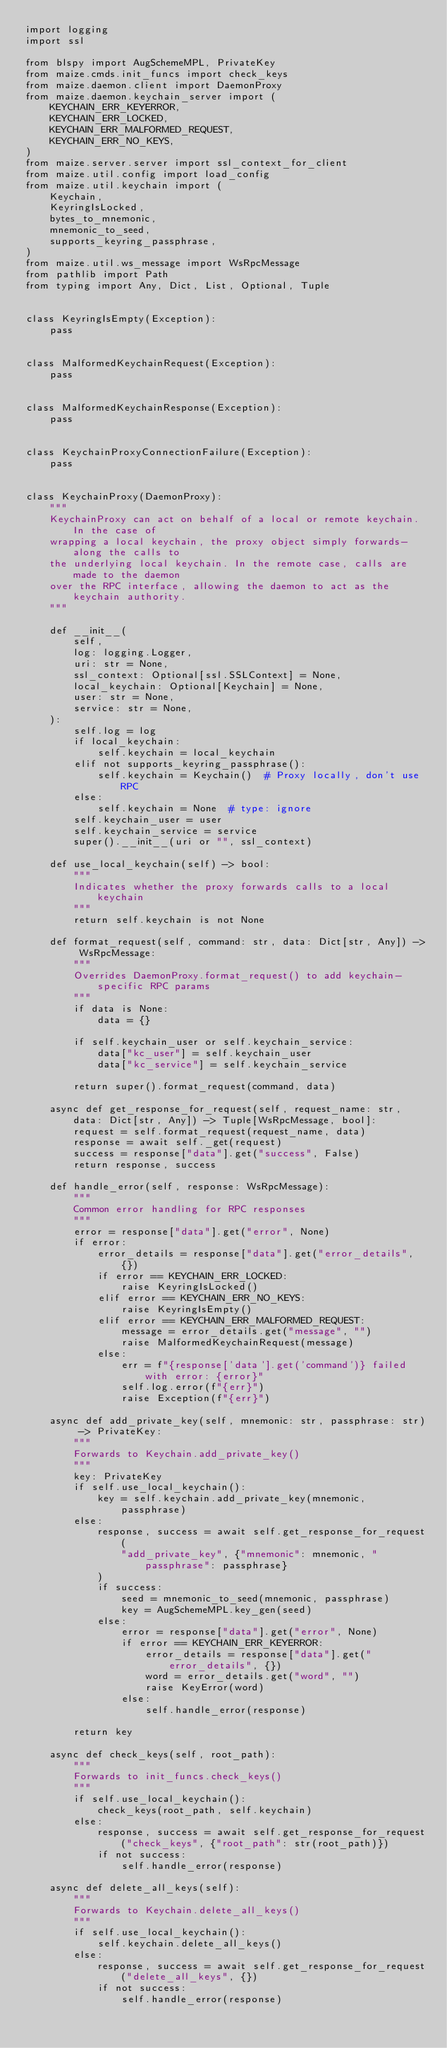<code> <loc_0><loc_0><loc_500><loc_500><_Python_>import logging
import ssl

from blspy import AugSchemeMPL, PrivateKey
from maize.cmds.init_funcs import check_keys
from maize.daemon.client import DaemonProxy
from maize.daemon.keychain_server import (
    KEYCHAIN_ERR_KEYERROR,
    KEYCHAIN_ERR_LOCKED,
    KEYCHAIN_ERR_MALFORMED_REQUEST,
    KEYCHAIN_ERR_NO_KEYS,
)
from maize.server.server import ssl_context_for_client
from maize.util.config import load_config
from maize.util.keychain import (
    Keychain,
    KeyringIsLocked,
    bytes_to_mnemonic,
    mnemonic_to_seed,
    supports_keyring_passphrase,
)
from maize.util.ws_message import WsRpcMessage
from pathlib import Path
from typing import Any, Dict, List, Optional, Tuple


class KeyringIsEmpty(Exception):
    pass


class MalformedKeychainRequest(Exception):
    pass


class MalformedKeychainResponse(Exception):
    pass


class KeychainProxyConnectionFailure(Exception):
    pass


class KeychainProxy(DaemonProxy):
    """
    KeychainProxy can act on behalf of a local or remote keychain. In the case of
    wrapping a local keychain, the proxy object simply forwards-along the calls to
    the underlying local keychain. In the remote case, calls are made to the daemon
    over the RPC interface, allowing the daemon to act as the keychain authority.
    """

    def __init__(
        self,
        log: logging.Logger,
        uri: str = None,
        ssl_context: Optional[ssl.SSLContext] = None,
        local_keychain: Optional[Keychain] = None,
        user: str = None,
        service: str = None,
    ):
        self.log = log
        if local_keychain:
            self.keychain = local_keychain
        elif not supports_keyring_passphrase():
            self.keychain = Keychain()  # Proxy locally, don't use RPC
        else:
            self.keychain = None  # type: ignore
        self.keychain_user = user
        self.keychain_service = service
        super().__init__(uri or "", ssl_context)

    def use_local_keychain(self) -> bool:
        """
        Indicates whether the proxy forwards calls to a local keychain
        """
        return self.keychain is not None

    def format_request(self, command: str, data: Dict[str, Any]) -> WsRpcMessage:
        """
        Overrides DaemonProxy.format_request() to add keychain-specific RPC params
        """
        if data is None:
            data = {}

        if self.keychain_user or self.keychain_service:
            data["kc_user"] = self.keychain_user
            data["kc_service"] = self.keychain_service

        return super().format_request(command, data)

    async def get_response_for_request(self, request_name: str, data: Dict[str, Any]) -> Tuple[WsRpcMessage, bool]:
        request = self.format_request(request_name, data)
        response = await self._get(request)
        success = response["data"].get("success", False)
        return response, success

    def handle_error(self, response: WsRpcMessage):
        """
        Common error handling for RPC responses
        """
        error = response["data"].get("error", None)
        if error:
            error_details = response["data"].get("error_details", {})
            if error == KEYCHAIN_ERR_LOCKED:
                raise KeyringIsLocked()
            elif error == KEYCHAIN_ERR_NO_KEYS:
                raise KeyringIsEmpty()
            elif error == KEYCHAIN_ERR_MALFORMED_REQUEST:
                message = error_details.get("message", "")
                raise MalformedKeychainRequest(message)
            else:
                err = f"{response['data'].get('command')} failed with error: {error}"
                self.log.error(f"{err}")
                raise Exception(f"{err}")

    async def add_private_key(self, mnemonic: str, passphrase: str) -> PrivateKey:
        """
        Forwards to Keychain.add_private_key()
        """
        key: PrivateKey
        if self.use_local_keychain():
            key = self.keychain.add_private_key(mnemonic, passphrase)
        else:
            response, success = await self.get_response_for_request(
                "add_private_key", {"mnemonic": mnemonic, "passphrase": passphrase}
            )
            if success:
                seed = mnemonic_to_seed(mnemonic, passphrase)
                key = AugSchemeMPL.key_gen(seed)
            else:
                error = response["data"].get("error", None)
                if error == KEYCHAIN_ERR_KEYERROR:
                    error_details = response["data"].get("error_details", {})
                    word = error_details.get("word", "")
                    raise KeyError(word)
                else:
                    self.handle_error(response)

        return key

    async def check_keys(self, root_path):
        """
        Forwards to init_funcs.check_keys()
        """
        if self.use_local_keychain():
            check_keys(root_path, self.keychain)
        else:
            response, success = await self.get_response_for_request("check_keys", {"root_path": str(root_path)})
            if not success:
                self.handle_error(response)

    async def delete_all_keys(self):
        """
        Forwards to Keychain.delete_all_keys()
        """
        if self.use_local_keychain():
            self.keychain.delete_all_keys()
        else:
            response, success = await self.get_response_for_request("delete_all_keys", {})
            if not success:
                self.handle_error(response)
</code> 